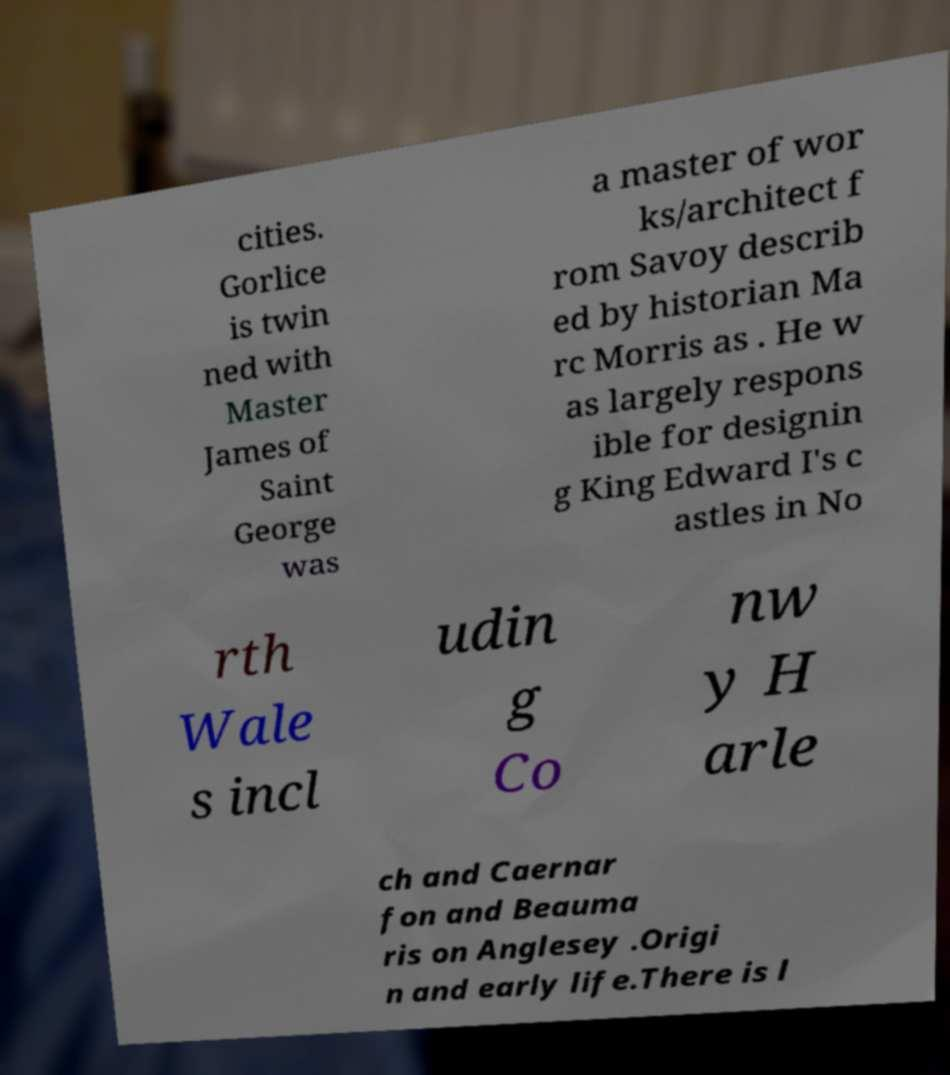For documentation purposes, I need the text within this image transcribed. Could you provide that? cities. Gorlice is twin ned with Master James of Saint George was a master of wor ks/architect f rom Savoy describ ed by historian Ma rc Morris as . He w as largely respons ible for designin g King Edward I's c astles in No rth Wale s incl udin g Co nw y H arle ch and Caernar fon and Beauma ris on Anglesey .Origi n and early life.There is l 